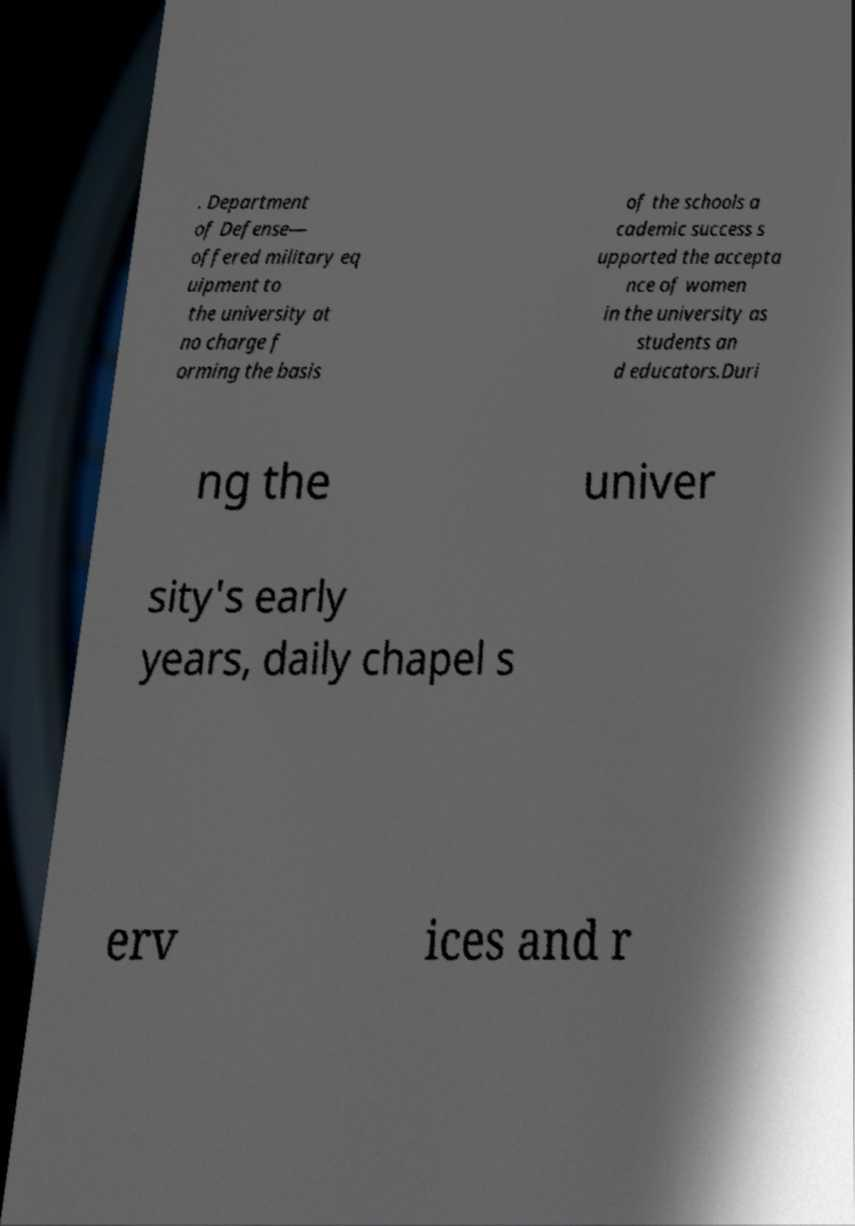Can you accurately transcribe the text from the provided image for me? . Department of Defense— offered military eq uipment to the university at no charge f orming the basis of the schools a cademic success s upported the accepta nce of women in the university as students an d educators.Duri ng the univer sity's early years, daily chapel s erv ices and r 